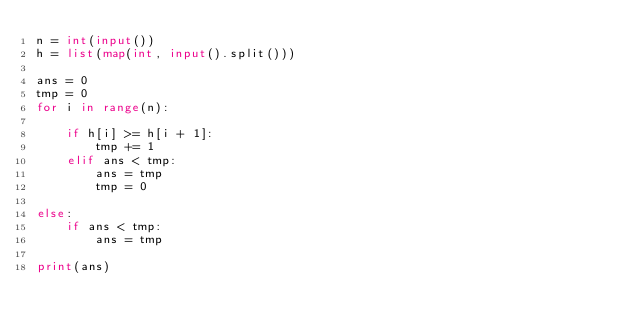Convert code to text. <code><loc_0><loc_0><loc_500><loc_500><_Python_>n = int(input())
h = list(map(int, input().split()))

ans = 0
tmp = 0
for i in range(n):

    if h[i] >= h[i + 1]:
        tmp += 1
    elif ans < tmp:
        ans = tmp
        tmp = 0
    
else:
    if ans < tmp:
        ans = tmp

print(ans)
</code> 